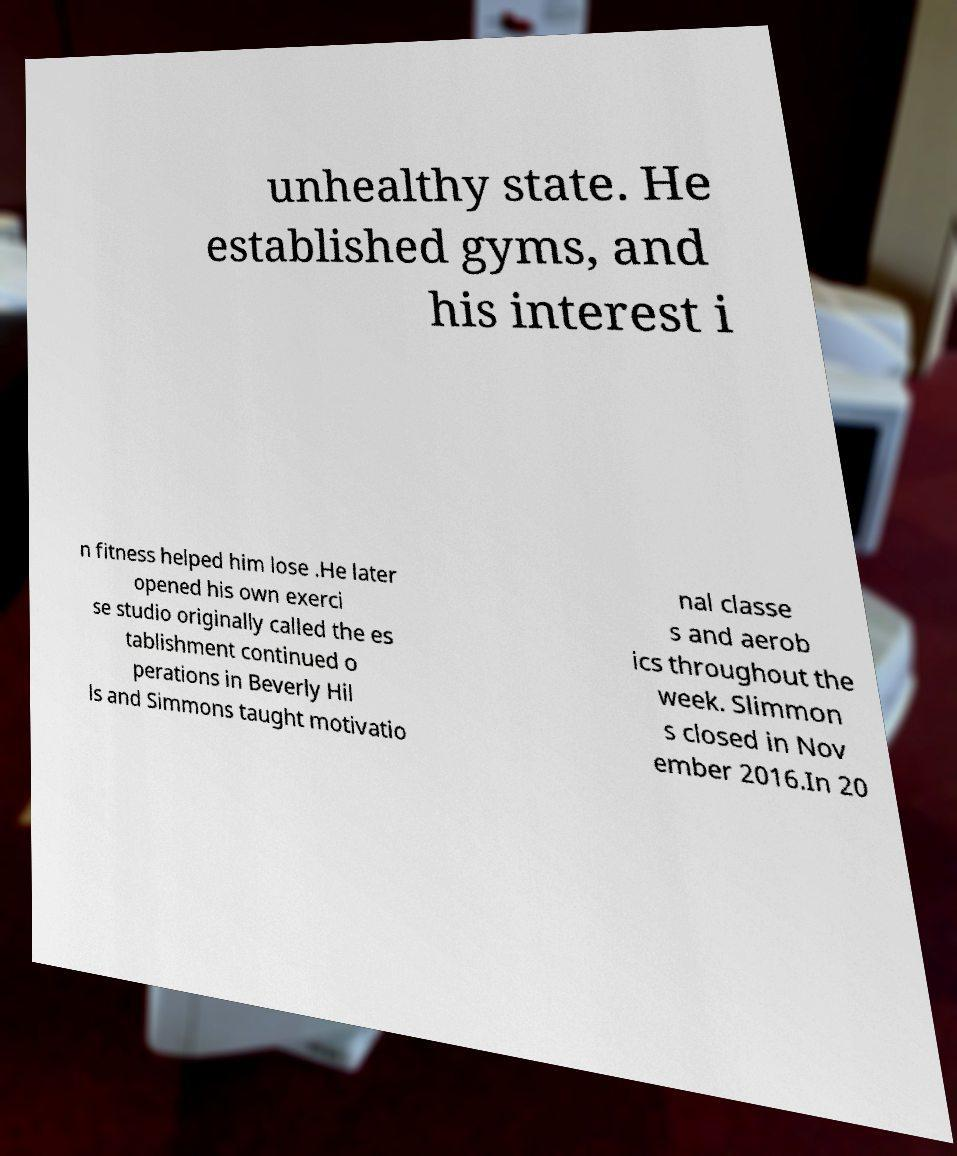Please read and relay the text visible in this image. What does it say? unhealthy state. He established gyms, and his interest i n fitness helped him lose .He later opened his own exerci se studio originally called the es tablishment continued o perations in Beverly Hil ls and Simmons taught motivatio nal classe s and aerob ics throughout the week. Slimmon s closed in Nov ember 2016.In 20 